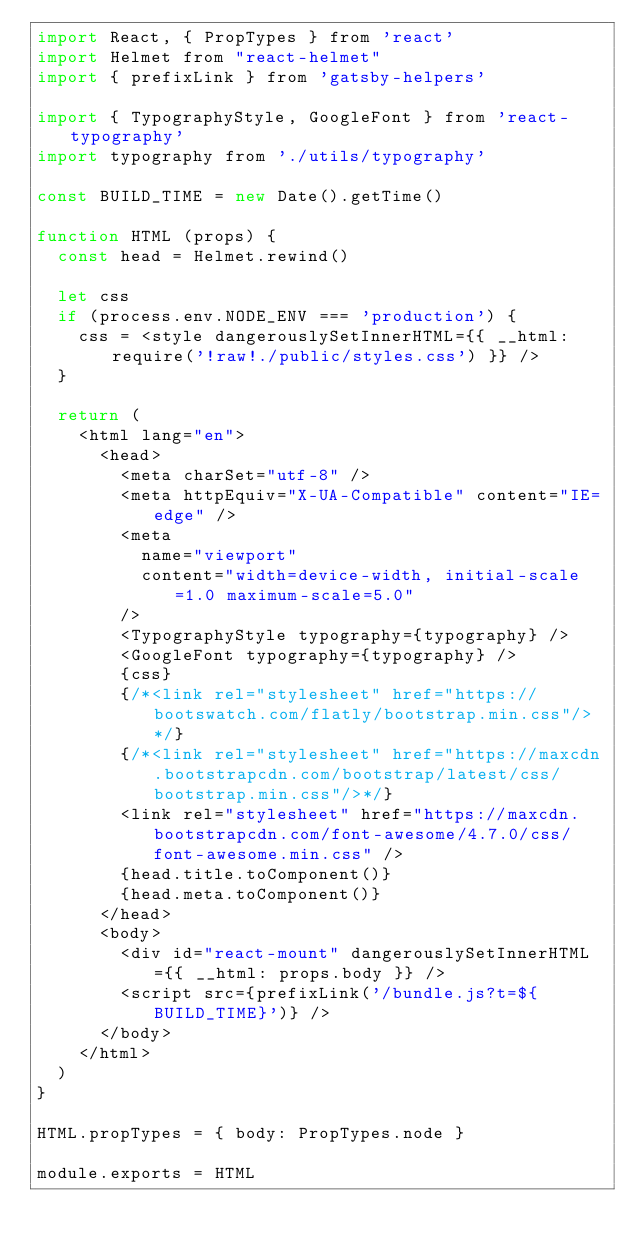Convert code to text. <code><loc_0><loc_0><loc_500><loc_500><_JavaScript_>import React, { PropTypes } from 'react'
import Helmet from "react-helmet"
import { prefixLink } from 'gatsby-helpers'

import { TypographyStyle, GoogleFont } from 'react-typography'
import typography from './utils/typography'

const BUILD_TIME = new Date().getTime()

function HTML (props) {
  const head = Helmet.rewind()

  let css
  if (process.env.NODE_ENV === 'production') {
    css = <style dangerouslySetInnerHTML={{ __html: require('!raw!./public/styles.css') }} />
  }

  return (
    <html lang="en">
      <head>
        <meta charSet="utf-8" />
        <meta httpEquiv="X-UA-Compatible" content="IE=edge" />
        <meta
          name="viewport"
          content="width=device-width, initial-scale=1.0 maximum-scale=5.0"
        />
        <TypographyStyle typography={typography} />
        <GoogleFont typography={typography} />
        {css}
        {/*<link rel="stylesheet" href="https://bootswatch.com/flatly/bootstrap.min.css"/>*/}
        {/*<link rel="stylesheet" href="https://maxcdn.bootstrapcdn.com/bootstrap/latest/css/bootstrap.min.css"/>*/}
        <link rel="stylesheet" href="https://maxcdn.bootstrapcdn.com/font-awesome/4.7.0/css/font-awesome.min.css" />
        {head.title.toComponent()}
        {head.meta.toComponent()}
      </head>
      <body>
        <div id="react-mount" dangerouslySetInnerHTML={{ __html: props.body }} />
        <script src={prefixLink('/bundle.js?t=${BUILD_TIME}')} />
      </body>
    </html>
  )
}

HTML.propTypes = { body: PropTypes.node }

module.exports = HTML
</code> 